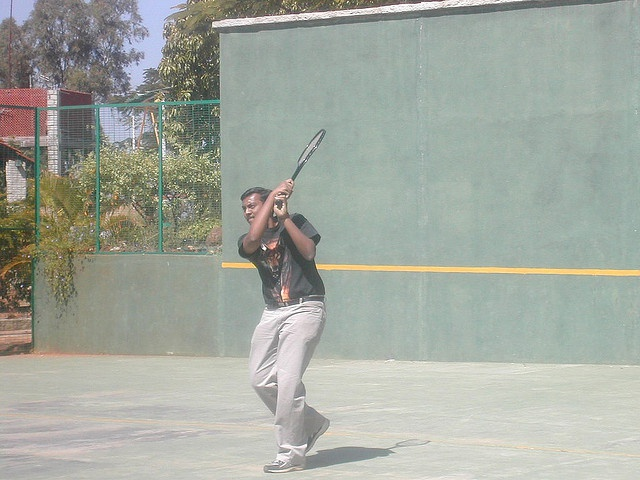Describe the objects in this image and their specific colors. I can see people in lavender, darkgray, gray, lightgray, and pink tones and tennis racket in lavender, darkgray, gray, and lightgray tones in this image. 